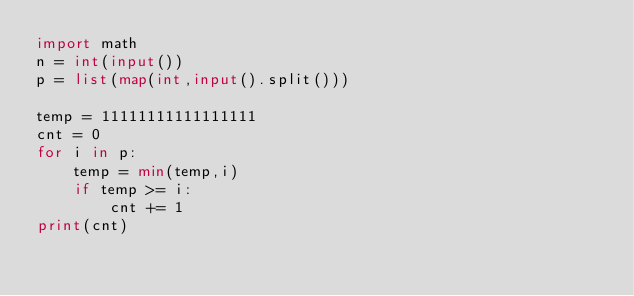<code> <loc_0><loc_0><loc_500><loc_500><_Python_>import math
n = int(input())
p = list(map(int,input().split()))

temp = 11111111111111111
cnt = 0
for i in p:
    temp = min(temp,i)
    if temp >= i:
        cnt += 1
print(cnt)

     </code> 